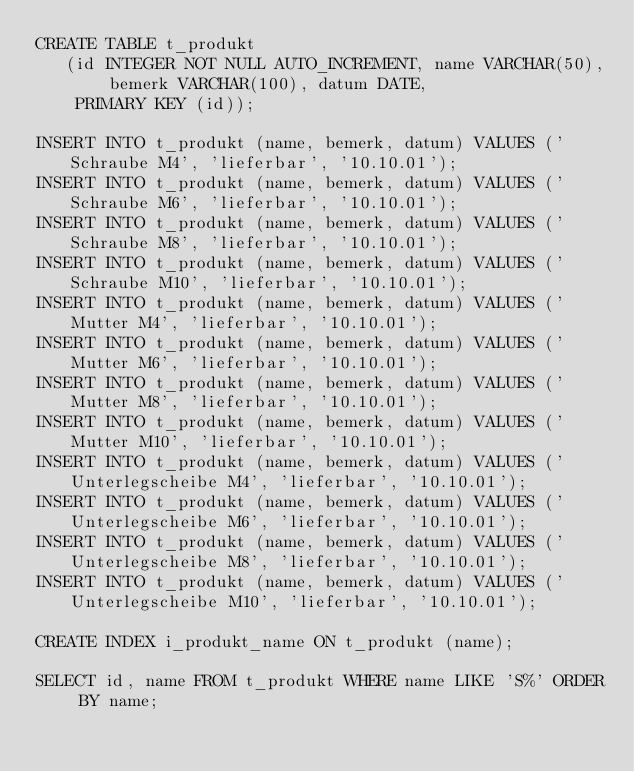Convert code to text. <code><loc_0><loc_0><loc_500><loc_500><_SQL_>CREATE TABLE t_produkt
   (id INTEGER NOT NULL AUTO_INCREMENT, name VARCHAR(50), bemerk VARCHAR(100), datum DATE,
    PRIMARY KEY (id));

INSERT INTO t_produkt (name, bemerk, datum) VALUES ('Schraube M4', 'lieferbar', '10.10.01');
INSERT INTO t_produkt (name, bemerk, datum) VALUES ('Schraube M6', 'lieferbar', '10.10.01');
INSERT INTO t_produkt (name, bemerk, datum) VALUES ('Schraube M8', 'lieferbar', '10.10.01');
INSERT INTO t_produkt (name, bemerk, datum) VALUES ('Schraube M10', 'lieferbar', '10.10.01');
INSERT INTO t_produkt (name, bemerk, datum) VALUES ('Mutter M4', 'lieferbar', '10.10.01');
INSERT INTO t_produkt (name, bemerk, datum) VALUES ('Mutter M6', 'lieferbar', '10.10.01');
INSERT INTO t_produkt (name, bemerk, datum) VALUES ('Mutter M8', 'lieferbar', '10.10.01');
INSERT INTO t_produkt (name, bemerk, datum) VALUES ('Mutter M10', 'lieferbar', '10.10.01');
INSERT INTO t_produkt (name, bemerk, datum) VALUES ('Unterlegscheibe M4', 'lieferbar', '10.10.01');
INSERT INTO t_produkt (name, bemerk, datum) VALUES ('Unterlegscheibe M6', 'lieferbar', '10.10.01');
INSERT INTO t_produkt (name, bemerk, datum) VALUES ('Unterlegscheibe M8', 'lieferbar', '10.10.01');
INSERT INTO t_produkt (name, bemerk, datum) VALUES ('Unterlegscheibe M10', 'lieferbar', '10.10.01');

CREATE INDEX i_produkt_name ON t_produkt (name);

SELECT id, name FROM t_produkt WHERE name LIKE 'S%' ORDER BY name; </code> 